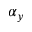<formula> <loc_0><loc_0><loc_500><loc_500>\alpha _ { y }</formula> 